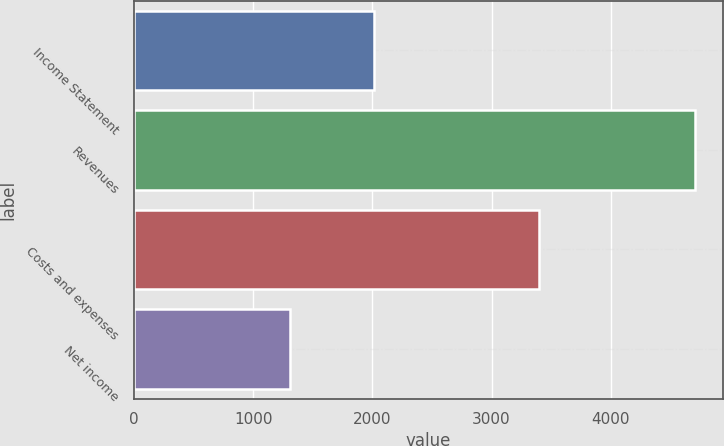Convert chart. <chart><loc_0><loc_0><loc_500><loc_500><bar_chart><fcel>Income Statement<fcel>Revenues<fcel>Costs and expenses<fcel>Net income<nl><fcel>2017<fcel>4703<fcel>3398<fcel>1305<nl></chart> 